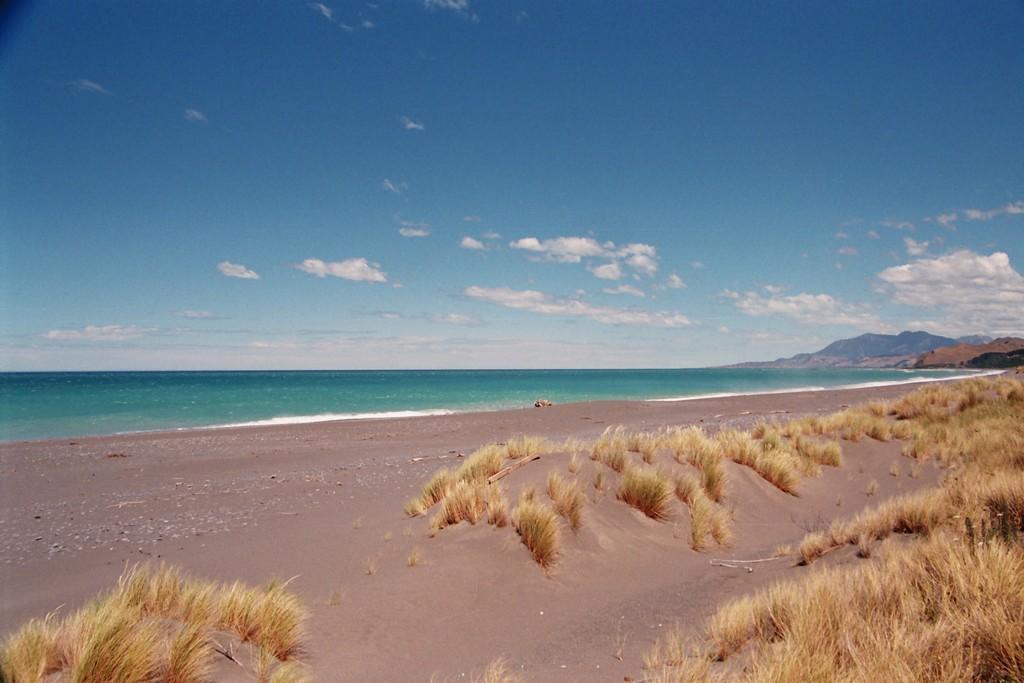In one or two sentences, can you explain what this image depicts? In this image I can see the ground, some grass on the ground which is brown in color. In the background I can see the water, few mountains and the sky. 